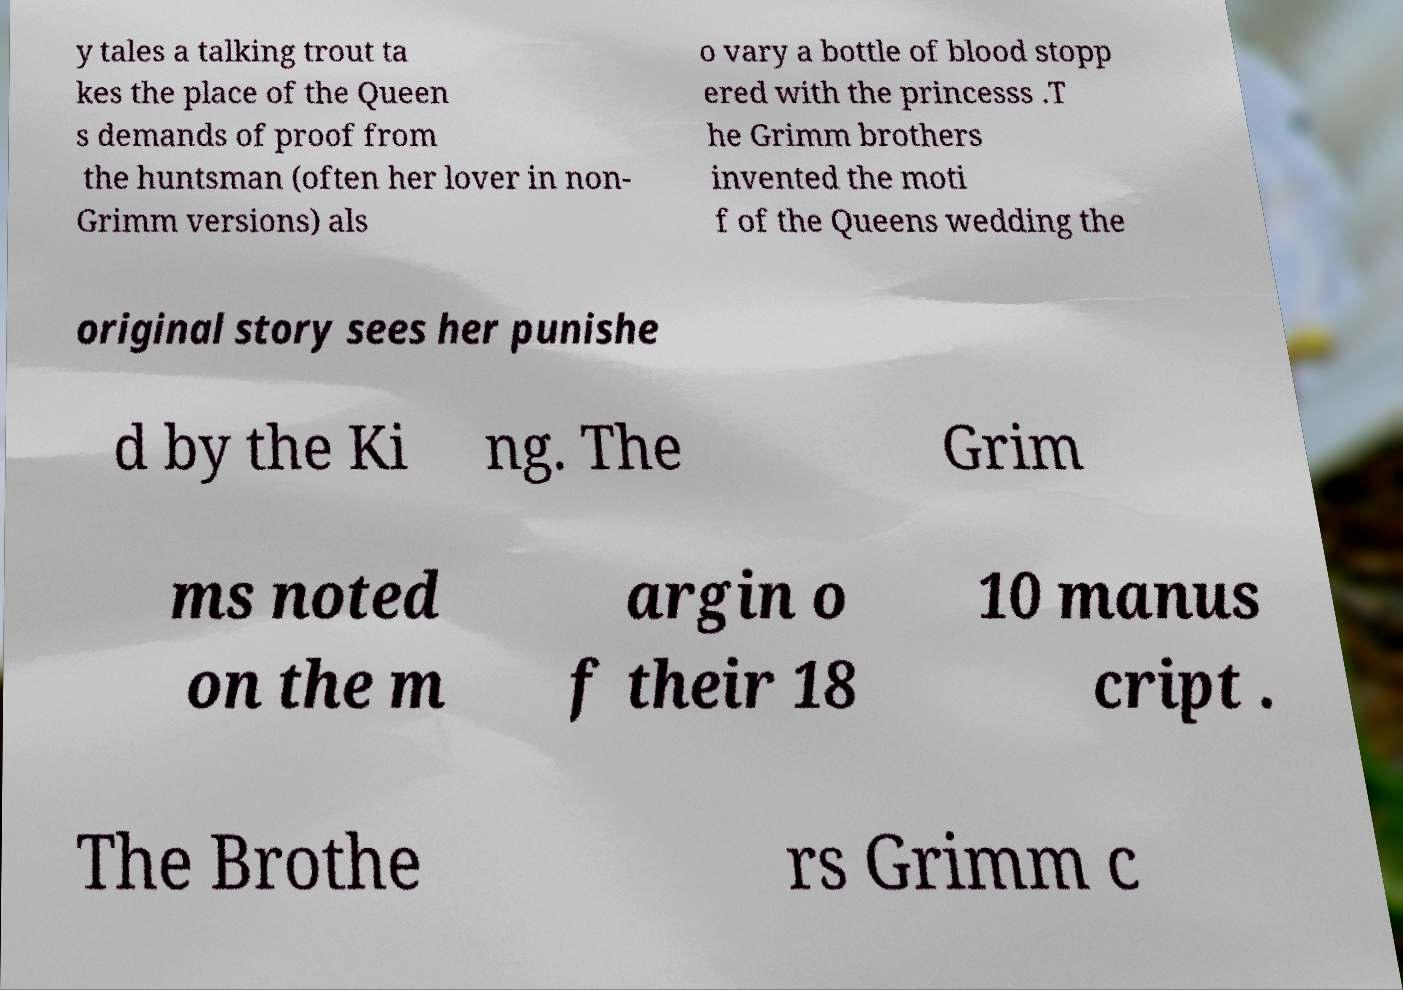Please identify and transcribe the text found in this image. y tales a talking trout ta kes the place of the Queen s demands of proof from the huntsman (often her lover in non- Grimm versions) als o vary a bottle of blood stopp ered with the princesss .T he Grimm brothers invented the moti f of the Queens wedding the original story sees her punishe d by the Ki ng. The Grim ms noted on the m argin o f their 18 10 manus cript . The Brothe rs Grimm c 